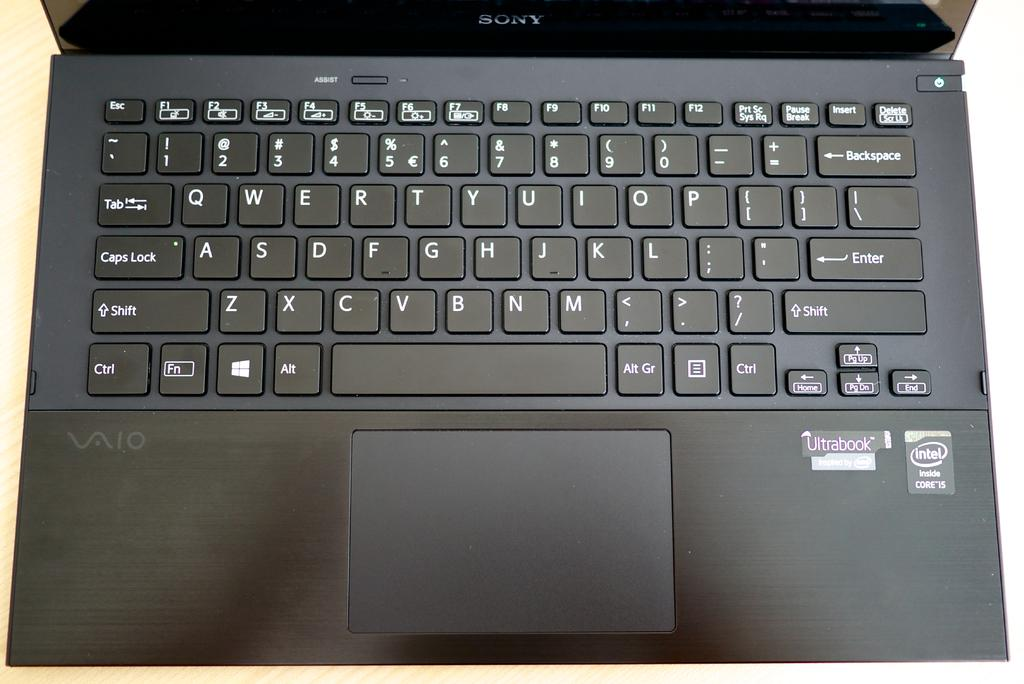<image>
Give a short and clear explanation of the subsequent image. Black Vaio laptop computer inspired by Intel Core 15. 